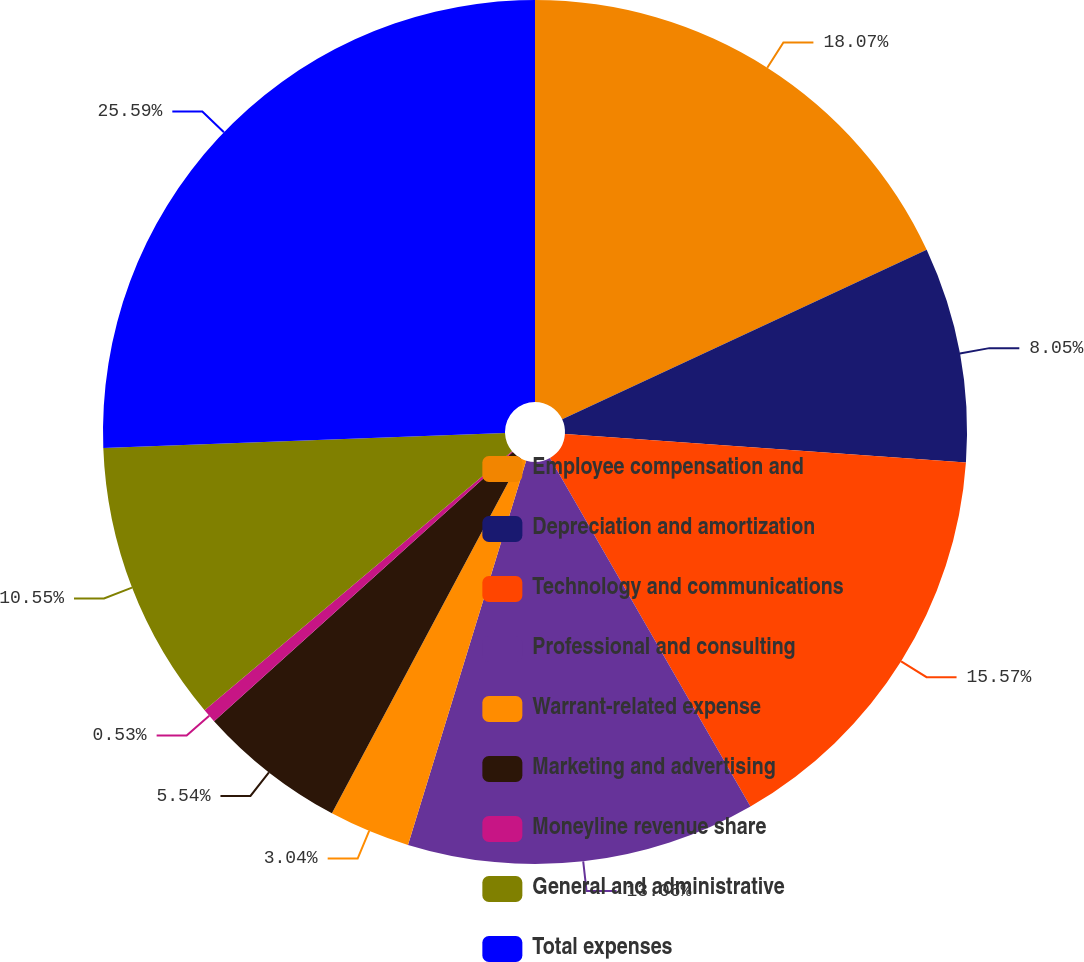Convert chart to OTSL. <chart><loc_0><loc_0><loc_500><loc_500><pie_chart><fcel>Employee compensation and<fcel>Depreciation and amortization<fcel>Technology and communications<fcel>Professional and consulting<fcel>Warrant-related expense<fcel>Marketing and advertising<fcel>Moneyline revenue share<fcel>General and administrative<fcel>Total expenses<nl><fcel>18.07%<fcel>8.05%<fcel>15.57%<fcel>13.06%<fcel>3.04%<fcel>5.54%<fcel>0.53%<fcel>10.55%<fcel>25.59%<nl></chart> 